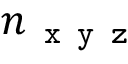<formula> <loc_0><loc_0><loc_500><loc_500>n _ { x y z }</formula> 